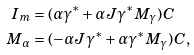Convert formula to latex. <formula><loc_0><loc_0><loc_500><loc_500>I _ { m } & = ( \alpha \gamma ^ { * } + \alpha J \gamma ^ { * } M _ { \gamma } ) C \\ M _ { \alpha } & = ( - \alpha J \gamma ^ { * } + \alpha \gamma ^ { * } M _ { \gamma } ) C ,</formula> 